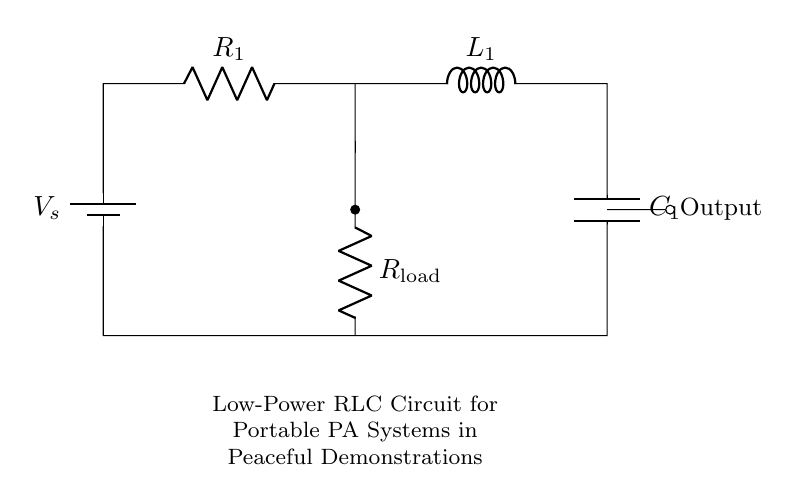What type of components are used in this circuit? The circuit consists of a resistor, an inductor, and a capacitor, which are the fundamental components of an RLC circuit.
Answer: Resistor, inductor, capacitor What is the purpose of the load resistor in the circuit? The load resistor converts electrical energy into usable power for the connected output, typically amplifying sound in a PA system.
Answer: Amplification What is the output connection in this circuit? The output is connected at the right side of the capacitor, allowing sound to be transmitted from the circuit to the external environment.
Answer: Output What is the total voltage supplied to the circuit? The battery is the voltage source placed at the top of the circuit, but the specific voltage value is not given; it is simply represented as V_s.
Answer: V_s How does the inductor affect the circuit's performance? The inductor stores energy in a magnetic field when current flows through it, influencing the phase and response of the circuit during AC operation, which is crucial for tuning frequency in PA applications.
Answer: Energy storage What determines the resonance frequency in this RLC circuit? The resonance frequency is determined by the values of the inductor and capacitor according to the formula: frequency equals one divided by two pi times the square root of the product of inductance and capacitance. This is key for effective sound amplification.
Answer: Inductance and capacitance What role does the capacitor play in the circuit? The capacitor stores and releases electrical energy in the circuit, creating a time delay for AC signals, which contributes to the filtering and frequency response necessary for audio clarity in a PA system.
Answer: Filtering and energy storage 